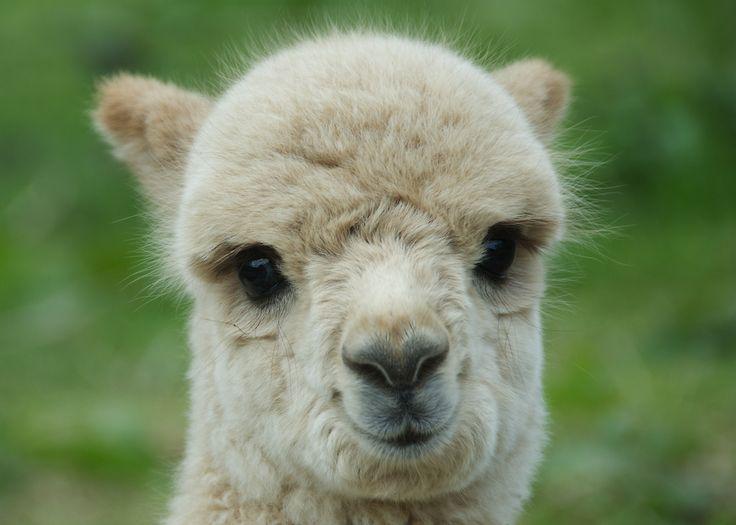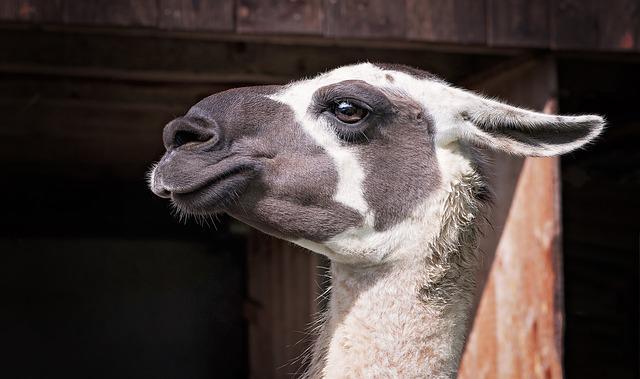The first image is the image on the left, the second image is the image on the right. Examine the images to the left and right. Is the description "The right image shows a single llama with its face in profile, and the left image shows a single llama with a round fuzzy head." accurate? Answer yes or no. Yes. 